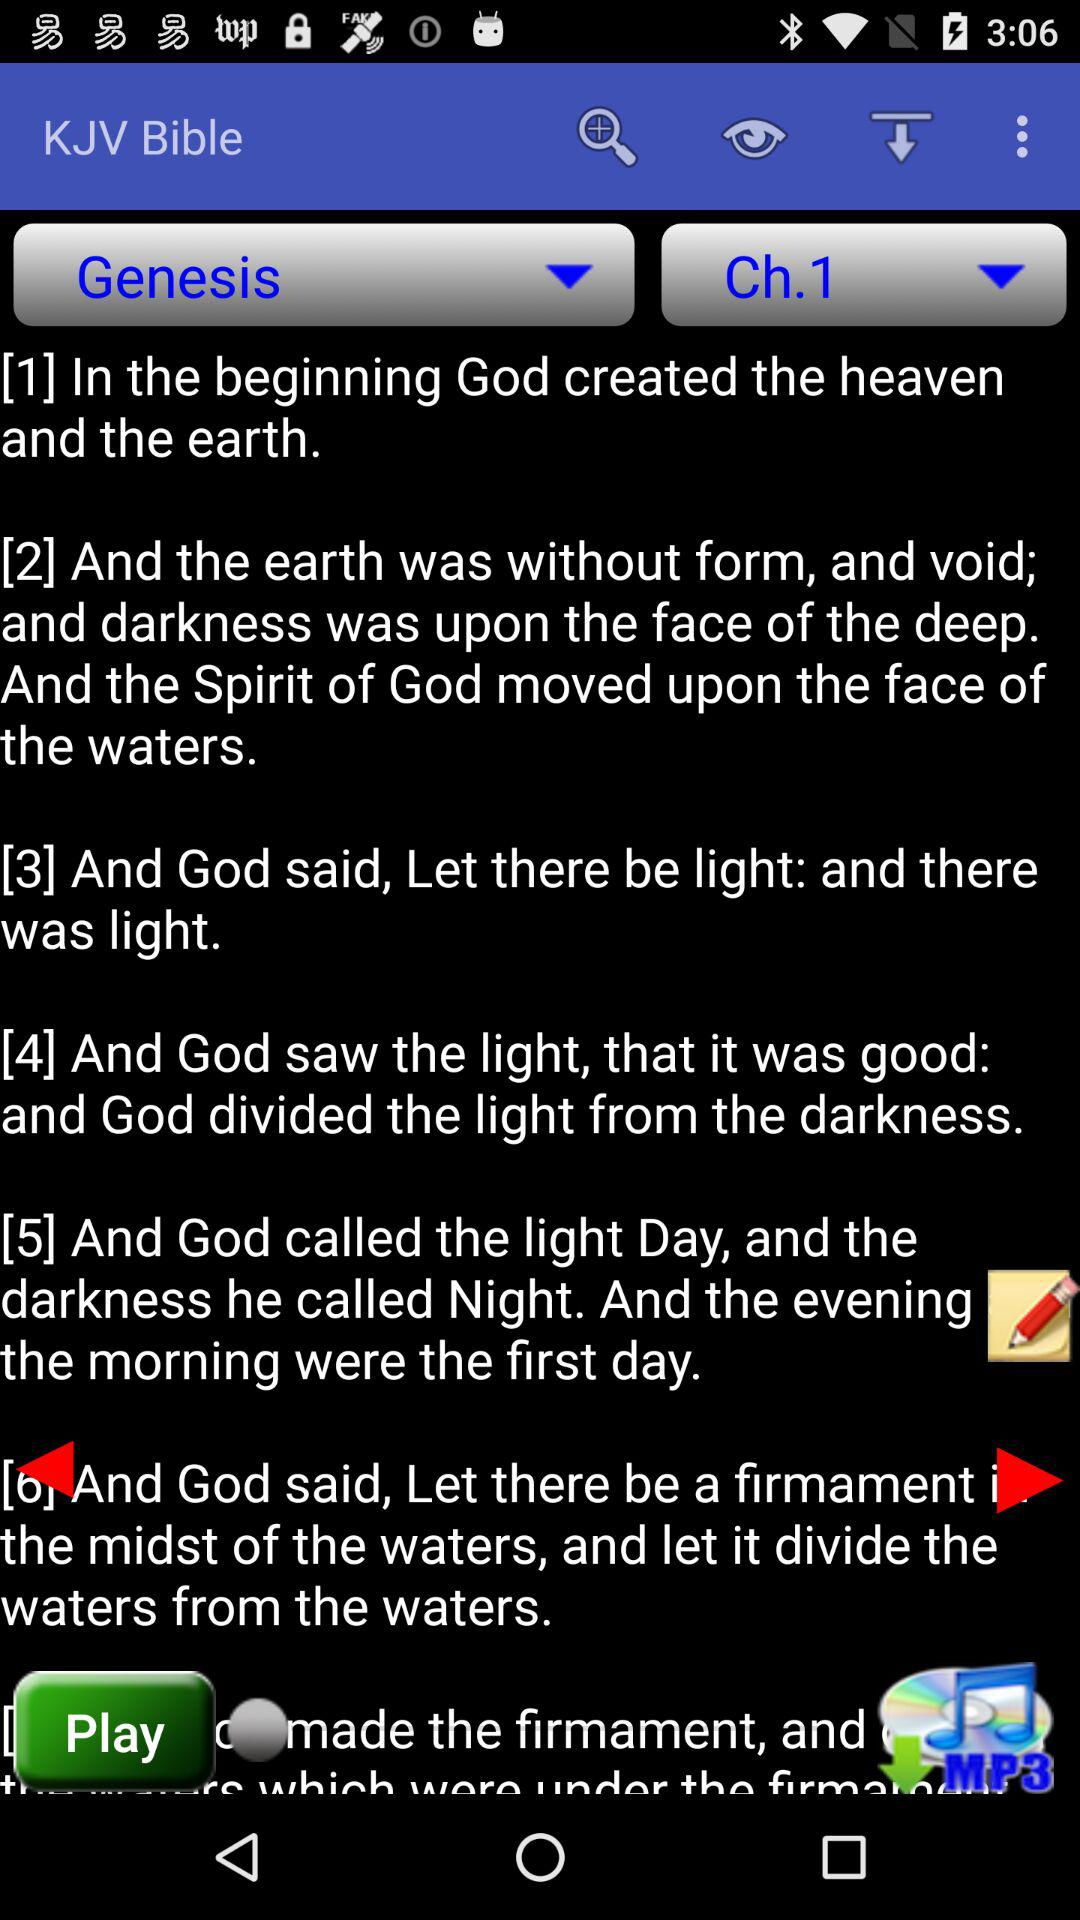Which chapter are we on now? You are on the first chapter. 